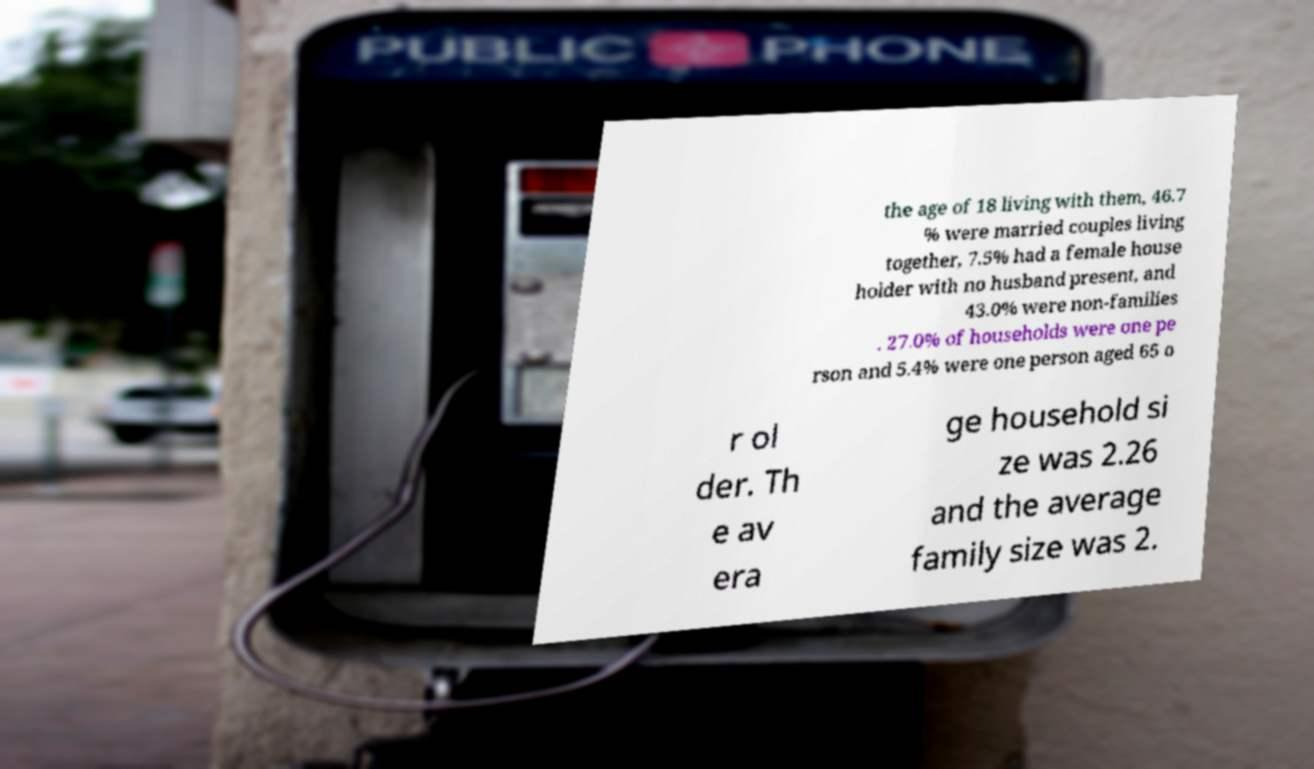For documentation purposes, I need the text within this image transcribed. Could you provide that? the age of 18 living with them, 46.7 % were married couples living together, 7.5% had a female house holder with no husband present, and 43.0% were non-families . 27.0% of households were one pe rson and 5.4% were one person aged 65 o r ol der. Th e av era ge household si ze was 2.26 and the average family size was 2. 